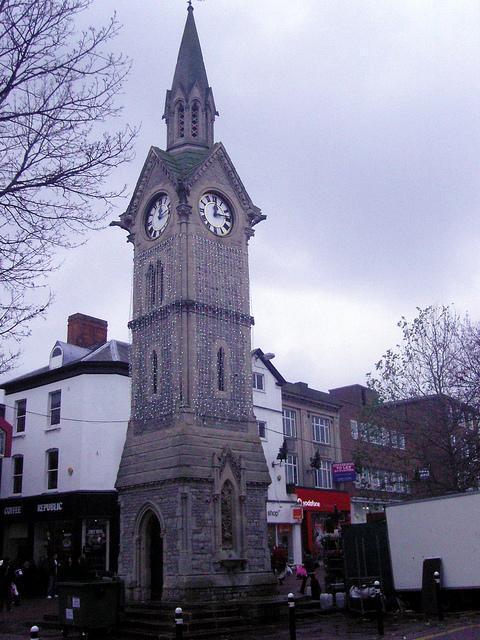What is near the apex of the tower?
From the following set of four choices, select the accurate answer to respond to the question.
Options: Clock, serpent, eagle, statue. Clock. 